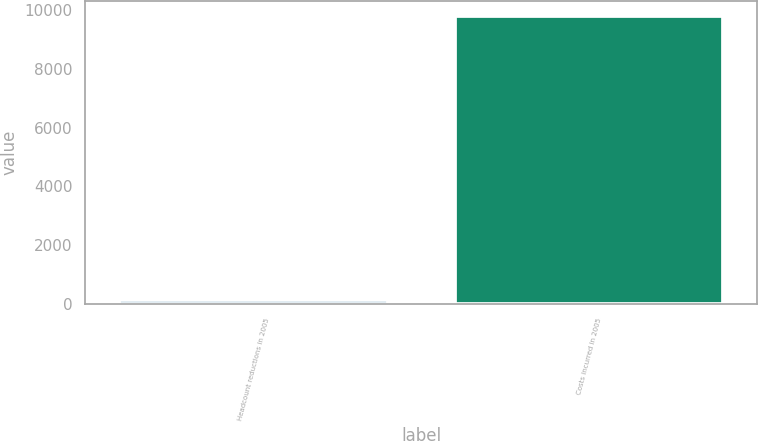Convert chart to OTSL. <chart><loc_0><loc_0><loc_500><loc_500><bar_chart><fcel>Headcount reductions in 2005<fcel>Costs incurred in 2005<nl><fcel>157<fcel>9799<nl></chart> 